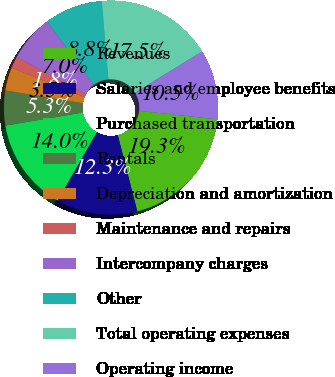<chart> <loc_0><loc_0><loc_500><loc_500><pie_chart><fcel>Revenues<fcel>Salaries and employee benefits<fcel>Purchased transportation<fcel>Rentals<fcel>Depreciation and amortization<fcel>Maintenance and repairs<fcel>Intercompany charges<fcel>Other<fcel>Total operating expenses<fcel>Operating income<nl><fcel>19.29%<fcel>12.28%<fcel>14.03%<fcel>5.27%<fcel>3.51%<fcel>1.76%<fcel>7.02%<fcel>8.77%<fcel>17.54%<fcel>10.53%<nl></chart> 